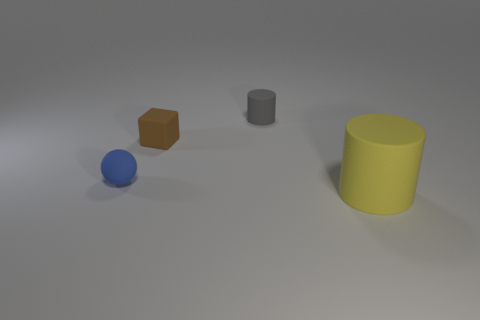There is a cylinder that is on the left side of the big yellow matte cylinder; how many small rubber cylinders are in front of it?
Provide a short and direct response. 0. How many rubber objects are both on the right side of the brown rubber block and behind the yellow rubber thing?
Keep it short and to the point. 1. What number of objects are small matte balls or rubber cylinders on the left side of the big thing?
Ensure brevity in your answer.  2. The gray cylinder that is made of the same material as the blue thing is what size?
Ensure brevity in your answer.  Small. There is a tiny brown thing that is in front of the object that is behind the brown block; what is its shape?
Ensure brevity in your answer.  Cube. What number of gray things are rubber spheres or tiny matte things?
Your response must be concise. 1. Is there a large matte thing that is behind the rubber cylinder that is in front of the rubber cylinder behind the tiny sphere?
Give a very brief answer. No. What number of big objects are either red blocks or brown cubes?
Provide a short and direct response. 0. There is a thing that is right of the small gray object; is it the same shape as the blue thing?
Your response must be concise. No. Is the number of yellow objects less than the number of tiny purple rubber balls?
Your response must be concise. No. 